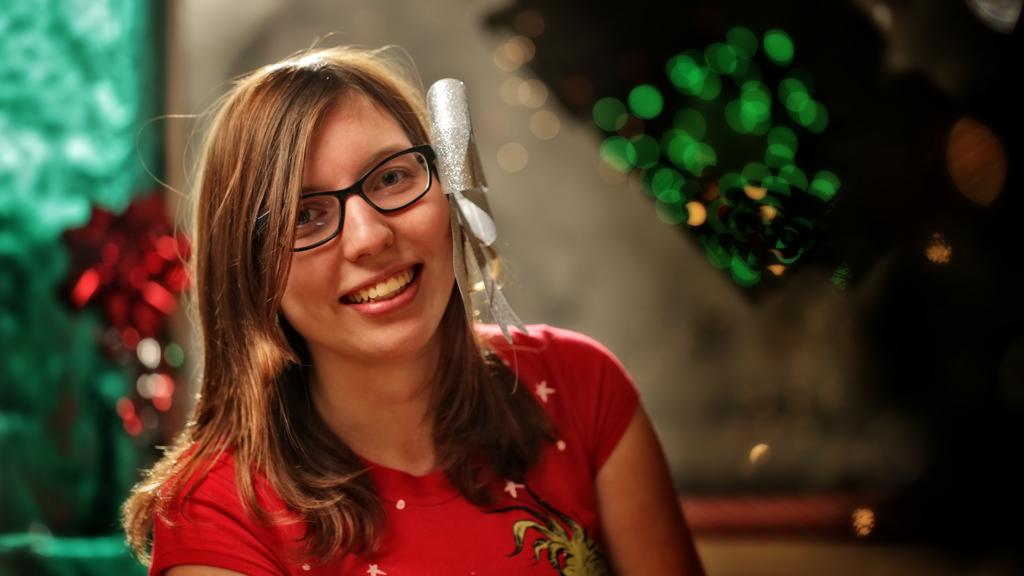What is the main subject of the image? There is a person in the image. What is the person doing in the image? The person is smiling. What other elements are present in the image besides the person? There are decorative items in the image. What type of desk can be seen in the image? There is no desk present in the image. Is the person carrying a bag in the image? The provided facts do not mention a bag, so it cannot be determined if the person is carrying one. Is the person swimming in the image? There is no indication in the image that the person is swimming, as the image does not depict a swimming scenario. 